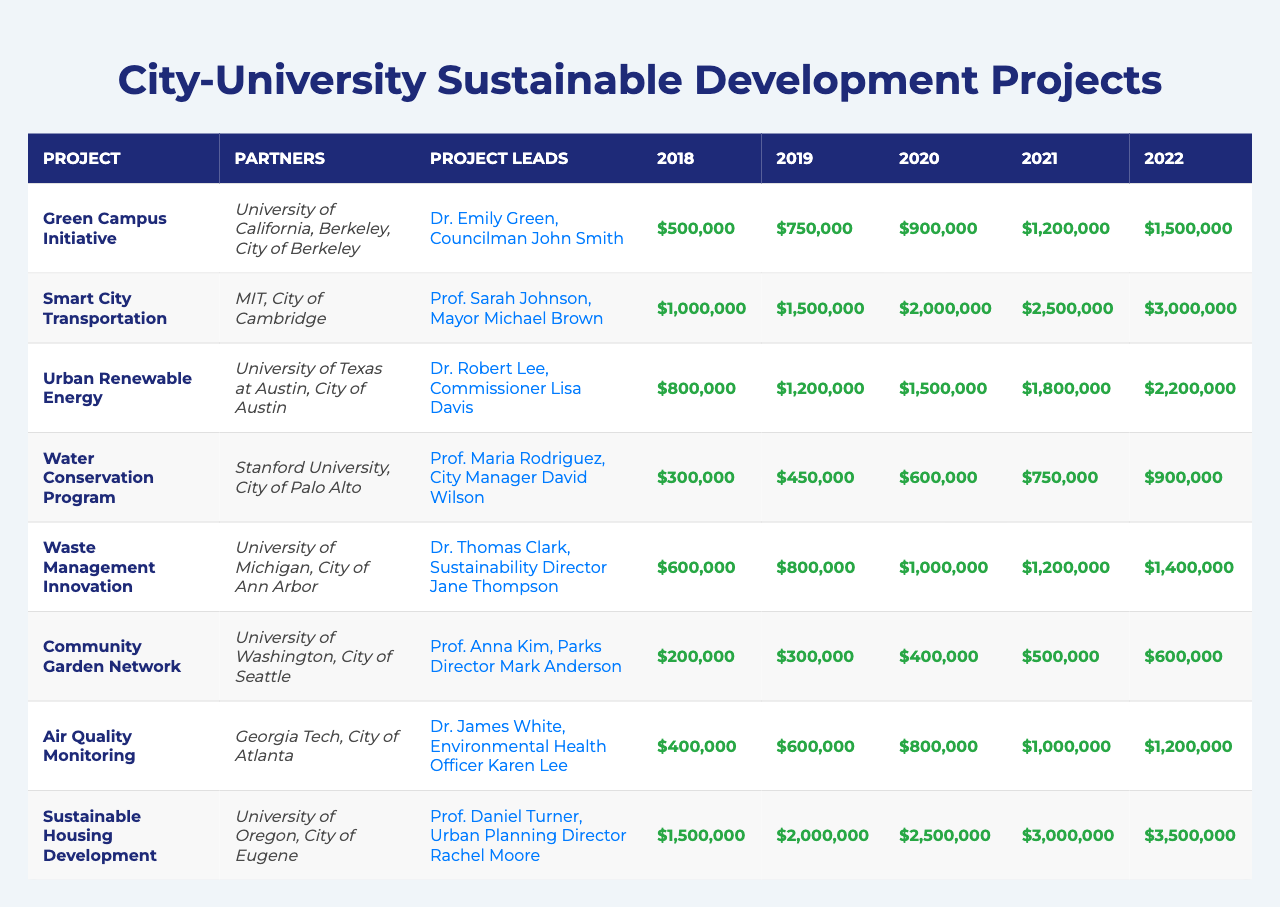What is the budget for the Green Campus Initiative in 2022? The budget for the Green Campus Initiative in 2022 is listed in the table, and it shows $1,500,000.
Answer: $1,500,000 Which project had the highest budget in 2020? The table shows that the Sustainable Housing Development project had the highest budget in 2020 at $2,500,000.
Answer: $2,500,000 What is the average budget for the Waste Management Innovation project from 2018 to 2022? To find the average, sum the budgets for Waste Management Innovation for the years 2018 to 2022: $600,000 + $800,000 + $1,000,000 + $1,200,000 + $1,400,000 = $5,000,000. Then divide by 5 (the number of years), so $5,000,000 / 5 = $1,000,000.
Answer: $1,000,000 Did the Urban Renewable Energy project receive an increasing budget each year? By examining the budgets for the Urban Renewable Energy project, they are $800,000, $1,200,000, $1,500,000, $1,800,000, and $2,200,000 from 2018 to 2022, which confirms that the budget increased each year.
Answer: Yes Which partner collaborated on the Smart City Transportation project and what was its total budget from 2018 to 2022? The Smart City Transportation project partnered with MIT and the City of Cambridge. Its total budget from 2018 to 2022 can be calculated as $1,000,000 + $1,500,000 + $2,000,000 + $2,500,000 + $3,000,000 = $10,000,000.
Answer: $10,000,000 What is the difference between the total budgets of the Community Garden Network and the Air Quality Monitoring projects over the five years? The total budget for Community Garden Network is $200,000 + $300,000 + $400,000 + $500,000 + $600,000 = $2,000,000. That for Air Quality Monitoring is $400,000 + $600,000 + $800,000 + $1,000,000 + $1,200,000 = $3,000,000. The difference is $3,000,000 - $2,000,000 = $1,000,000.
Answer: $1,000,000 Which project had the lowest budget in the year 2019? The table shows that the Community Garden Network had the lowest budget in 2019, which is $300,000.
Answer: $300,000 What is the overall budget trend for the Sustainable Housing Development project? The budgets show an increasing trend: $1,500,000 in 2018, $2,000,000 in 2019, $2,500,000 in 2020, $3,000,000 in 2021, and $3,500,000 in 2022, demonstrating consistent growth.
Answer: Increasing Which project led by a city official had the largest budget in 2021? According to the table, the project led by a city official with the largest budget in 2021 is Sustainable Housing Development, which had a budget of $3,000,000.
Answer: Sustainable Housing Development Over the years, what is the total budget for the Water Conservation Program? The total budget for the Water Conservation Program from 2018 to 2022 can be calculated as $300,000 + $450,000 + $600,000 + $750,000 + $900,000 = $3,000,000.
Answer: $3,000,000 